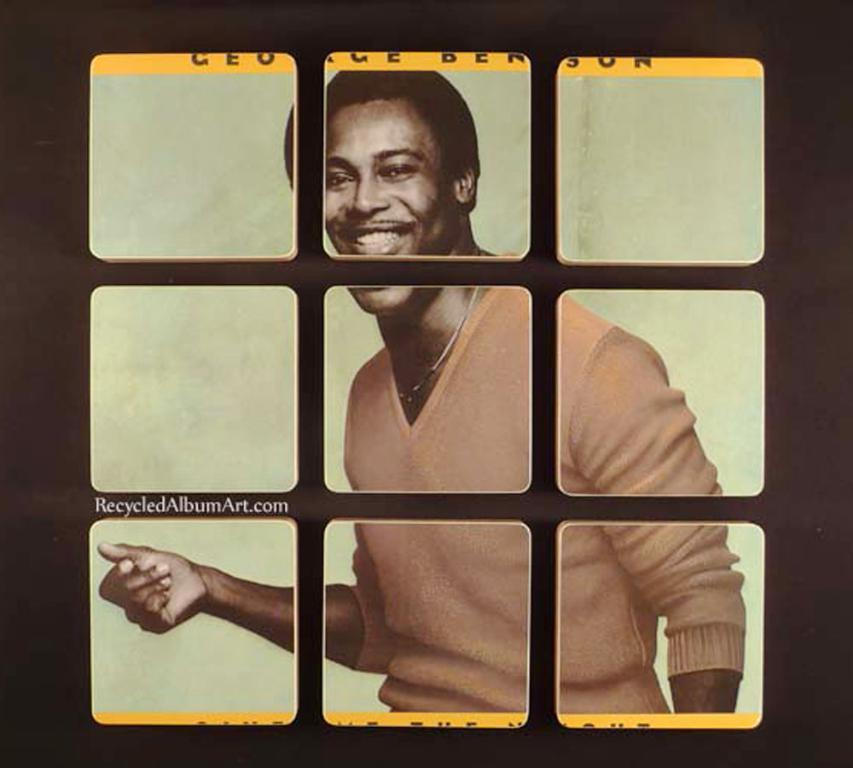What design is featured on the carriage in the image? There is no carriage present in the image, so it is not possible to answer that question. 